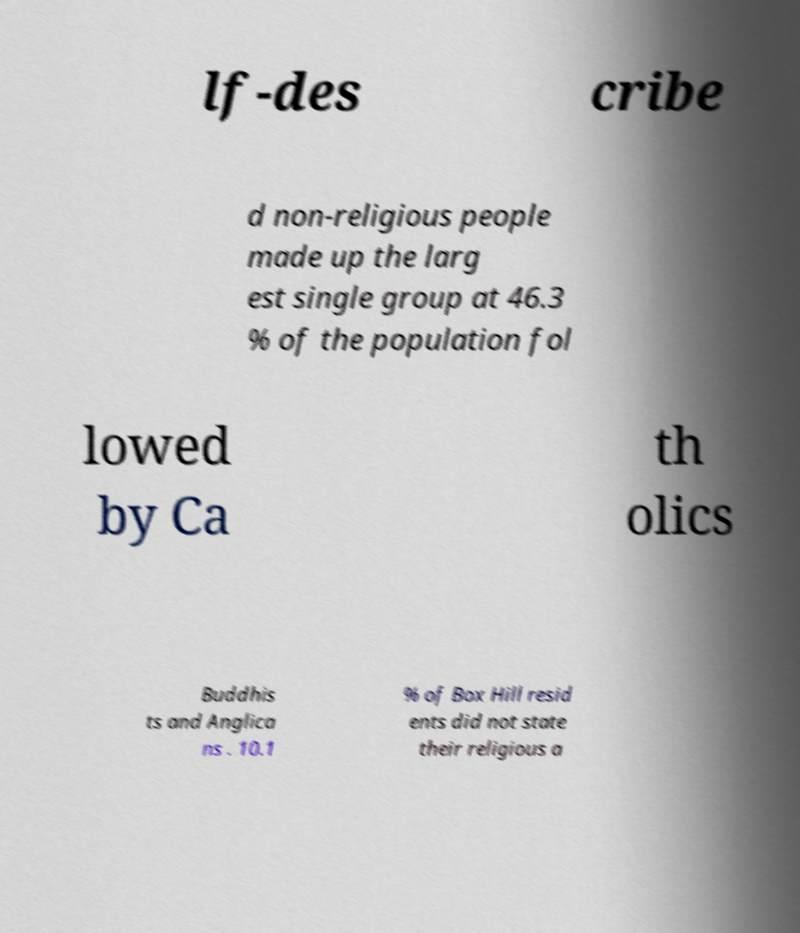I need the written content from this picture converted into text. Can you do that? lf-des cribe d non-religious people made up the larg est single group at 46.3 % of the population fol lowed by Ca th olics Buddhis ts and Anglica ns . 10.1 % of Box Hill resid ents did not state their religious a 